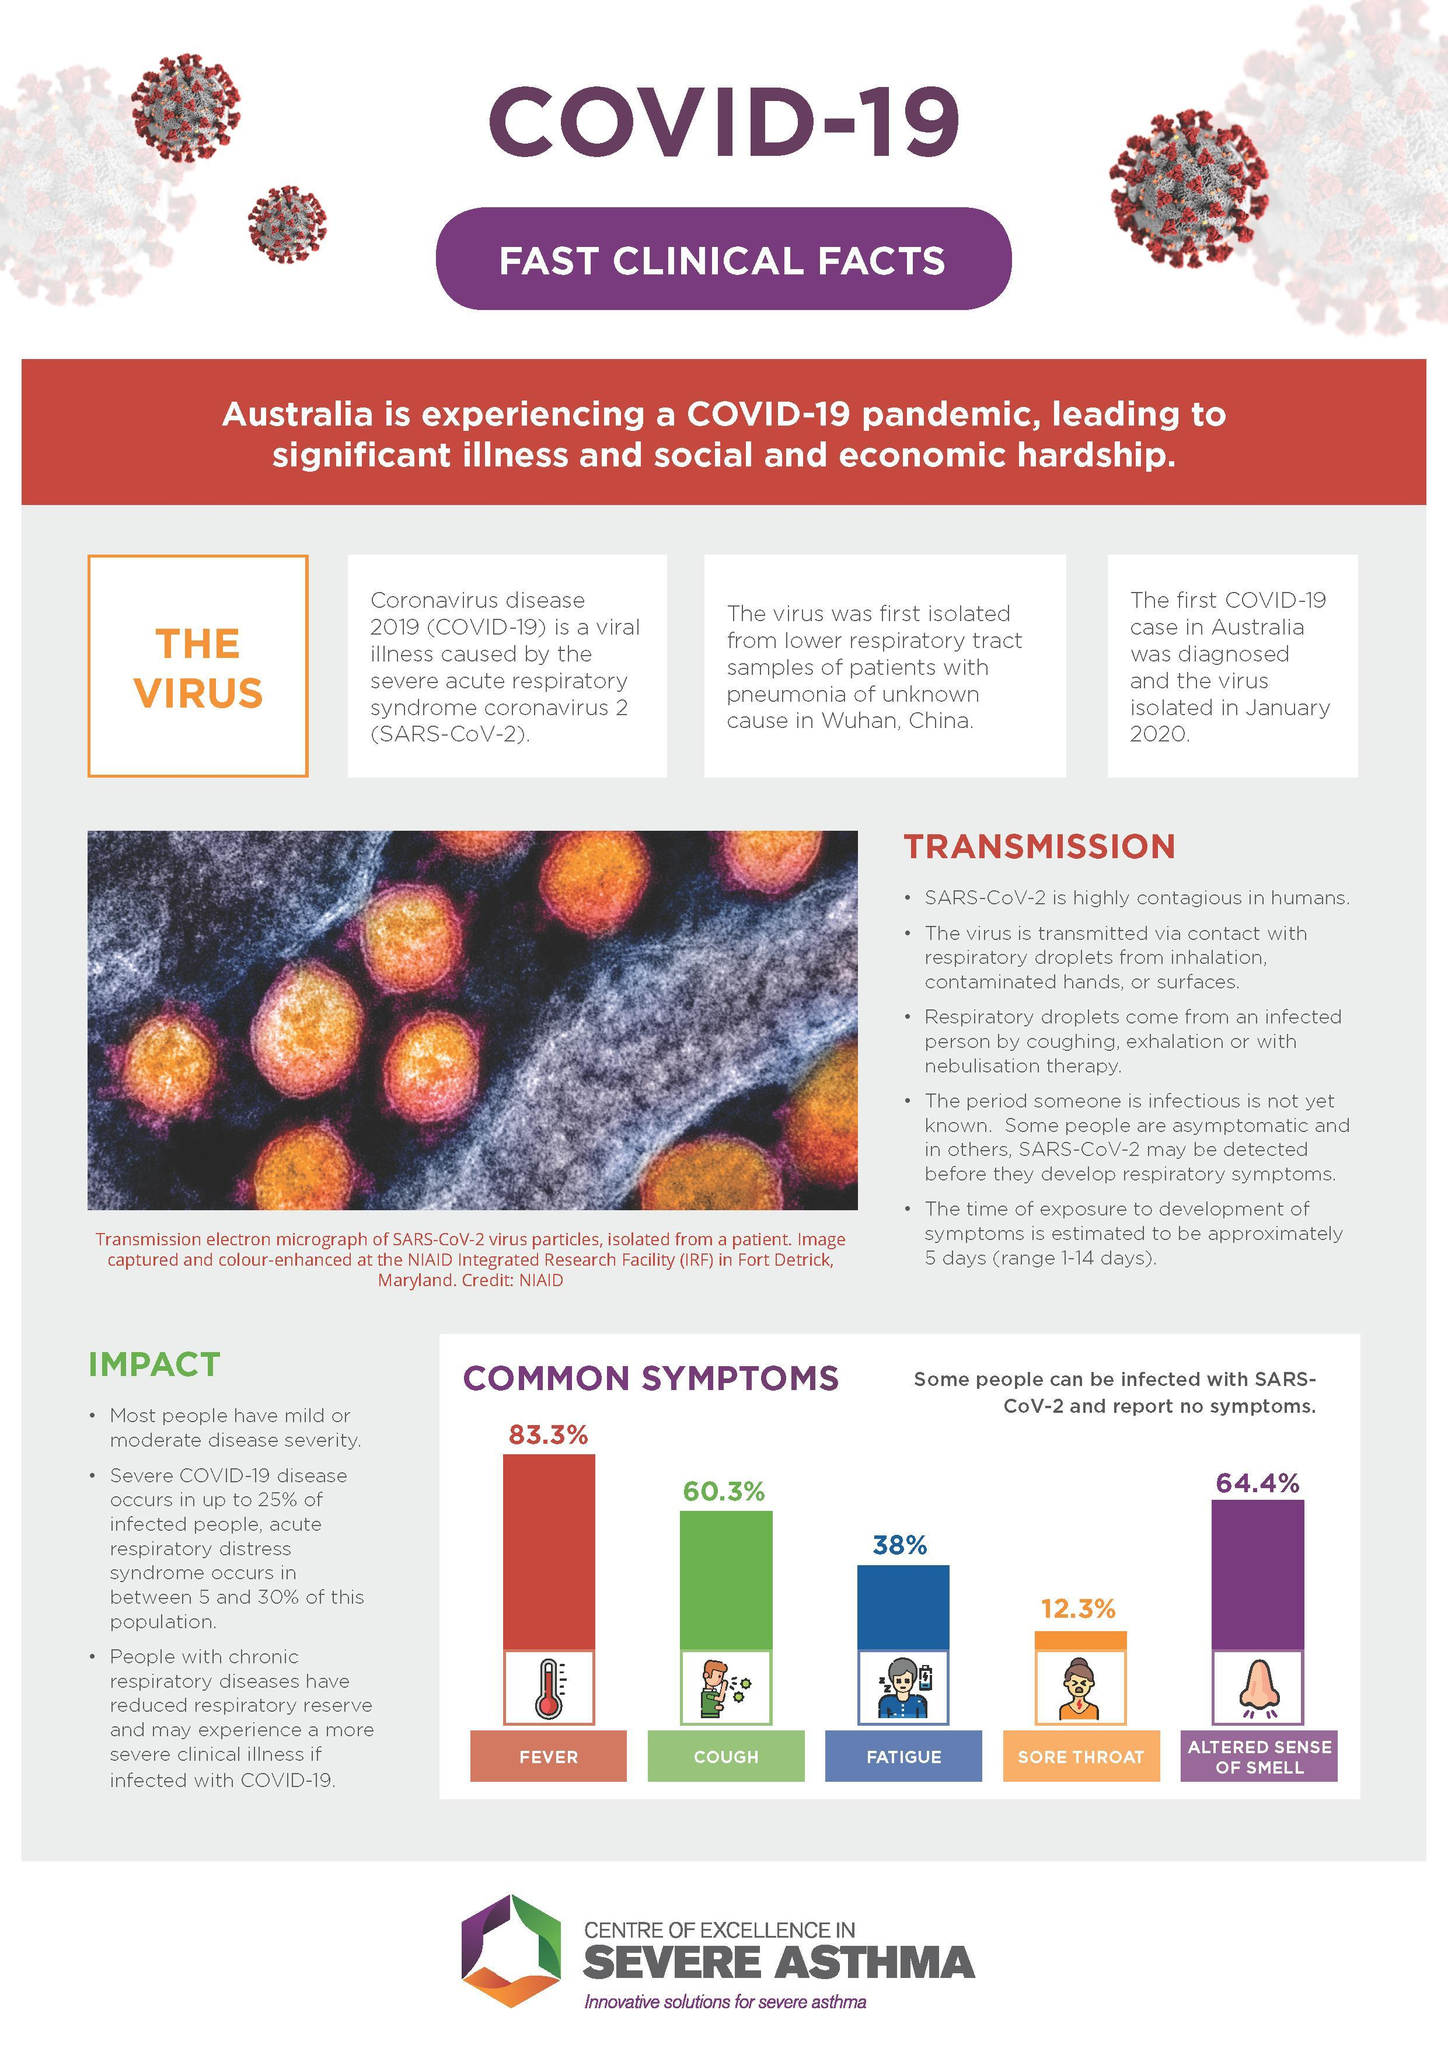which is the least common symptom among infected paitents?
Answer the question with a short phrase. sore throat which symptom is commonly shown by most of the covid-19 paitents? fever the virus got isolated in which country, China or Australia? Australia whether cough or altered sense of smell is the most common symptom shown by the infected people? altered sense of smell In which country, China or australia, did the virus got first isolated? China 